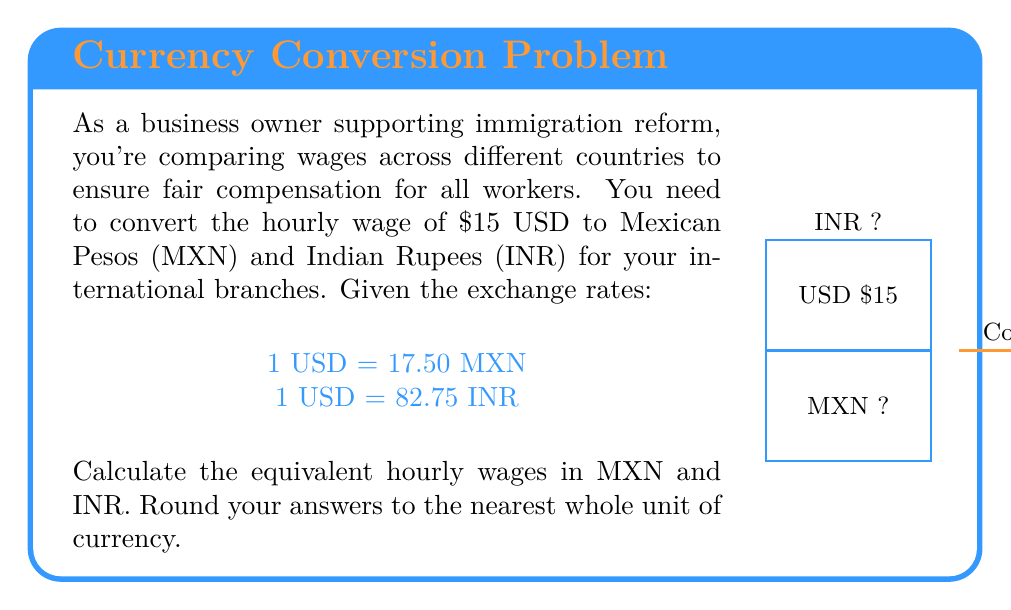Show me your answer to this math problem. Let's convert the USD wage to MXN and INR step by step:

1. Converting USD to MXN:
   $$ 15 \text{ USD} \times \frac{17.50 \text{ MXN}}{1 \text{ USD}} = 262.50 \text{ MXN} $$
   Rounding to the nearest whole unit: 263 MXN

2. Converting USD to INR:
   $$ 15 \text{ USD} \times \frac{82.75 \text{ INR}}{1 \text{ USD}} = 1241.25 \text{ INR} $$
   Rounding to the nearest whole unit: 1241 INR

The conversions use the given exchange rates and multiply them by the USD wage. Rounding is done to provide practical wage figures in each currency.
Answer: 263 MXN, 1241 INR 